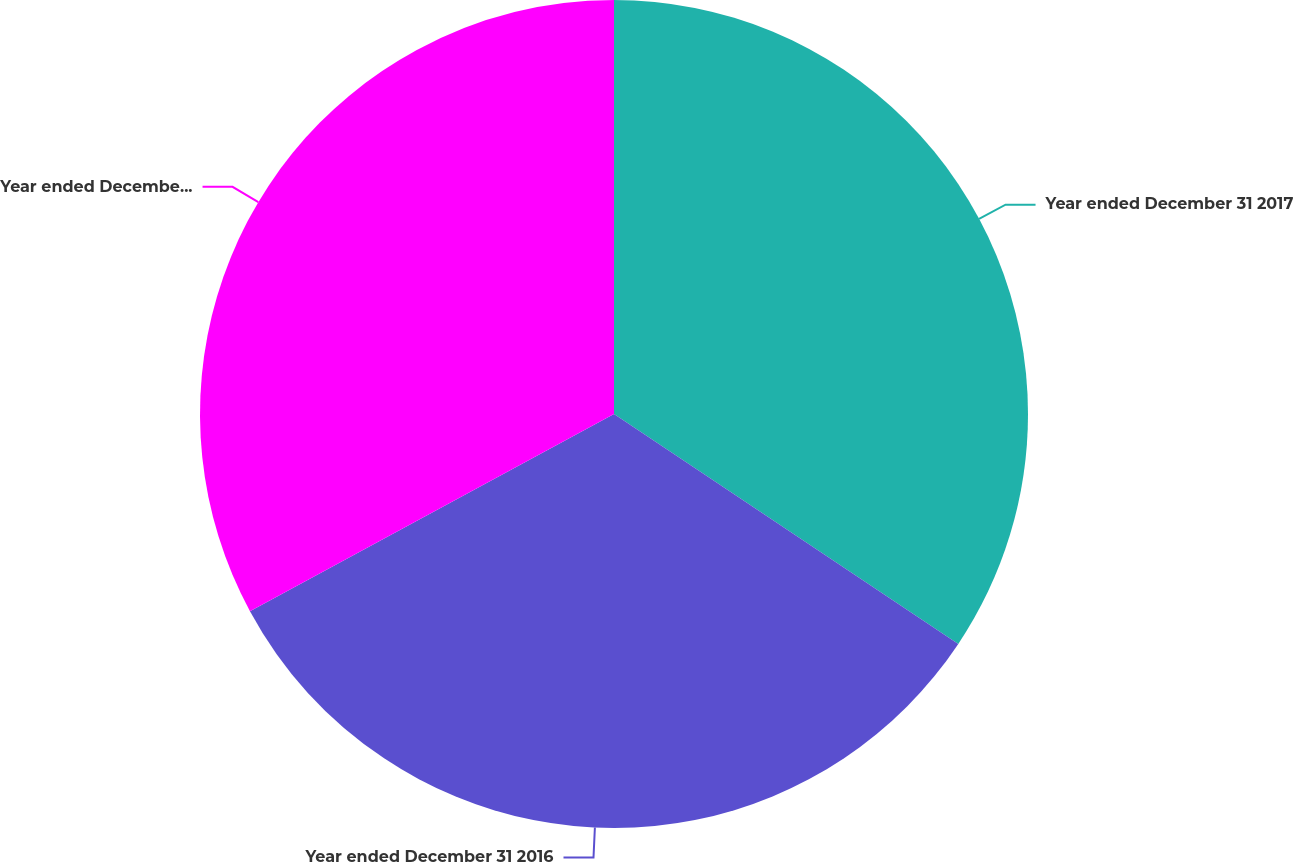Convert chart to OTSL. <chart><loc_0><loc_0><loc_500><loc_500><pie_chart><fcel>Year ended December 31 2017<fcel>Year ended December 31 2016<fcel>Year ended December 31 2015<nl><fcel>34.37%<fcel>32.73%<fcel>32.9%<nl></chart> 